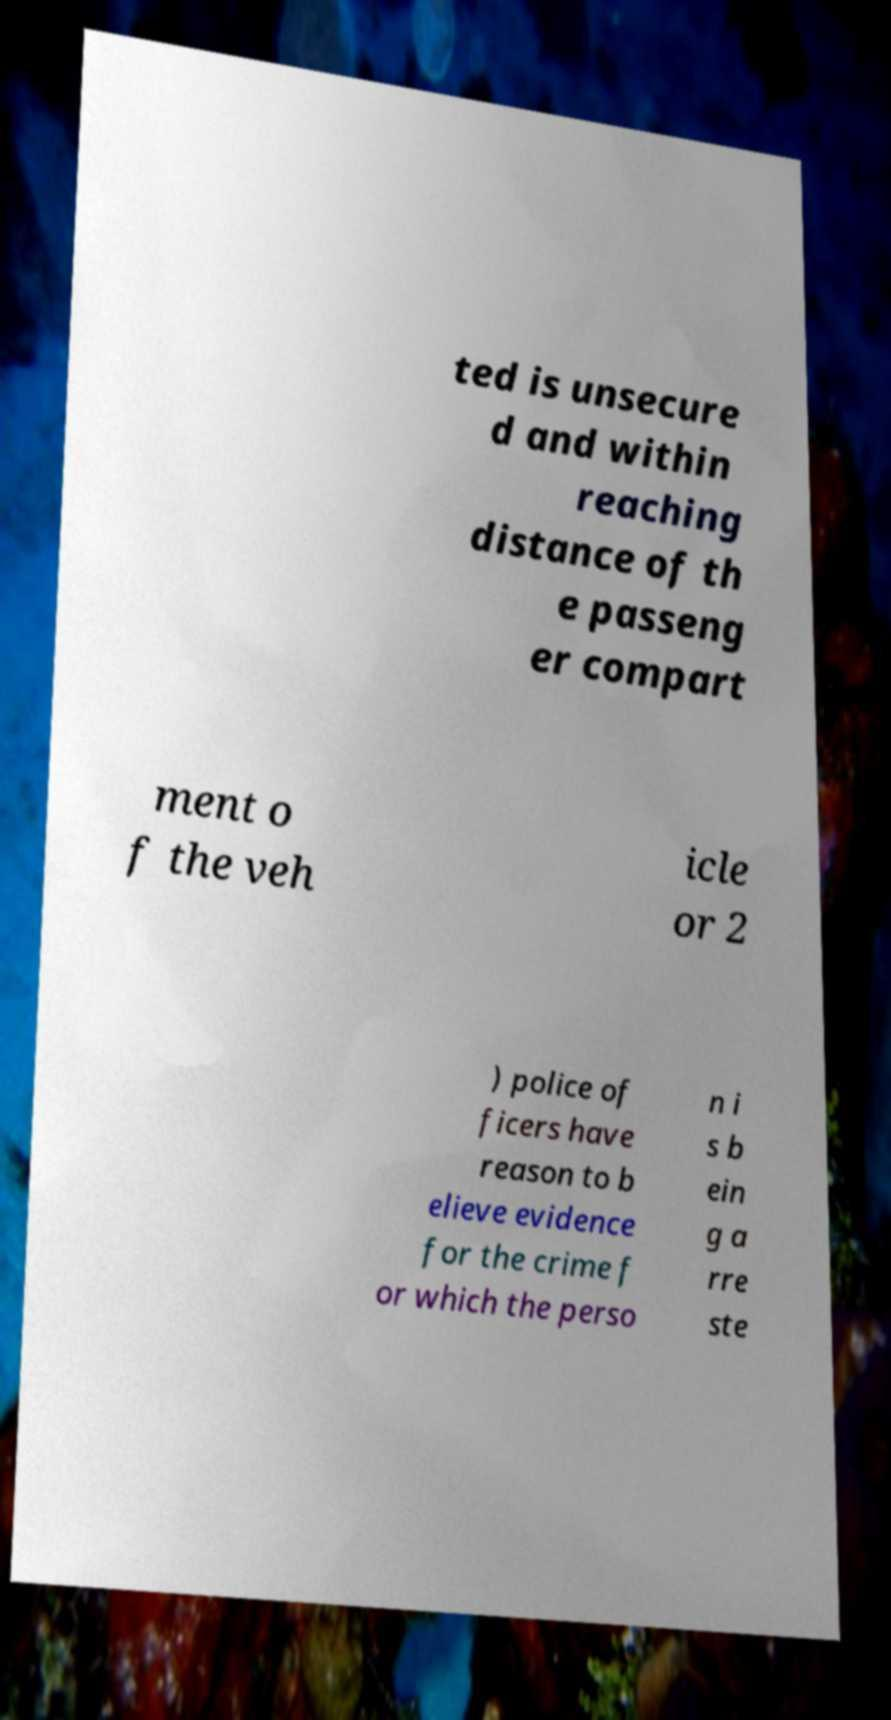Could you extract and type out the text from this image? ted is unsecure d and within reaching distance of th e passeng er compart ment o f the veh icle or 2 ) police of ficers have reason to b elieve evidence for the crime f or which the perso n i s b ein g a rre ste 